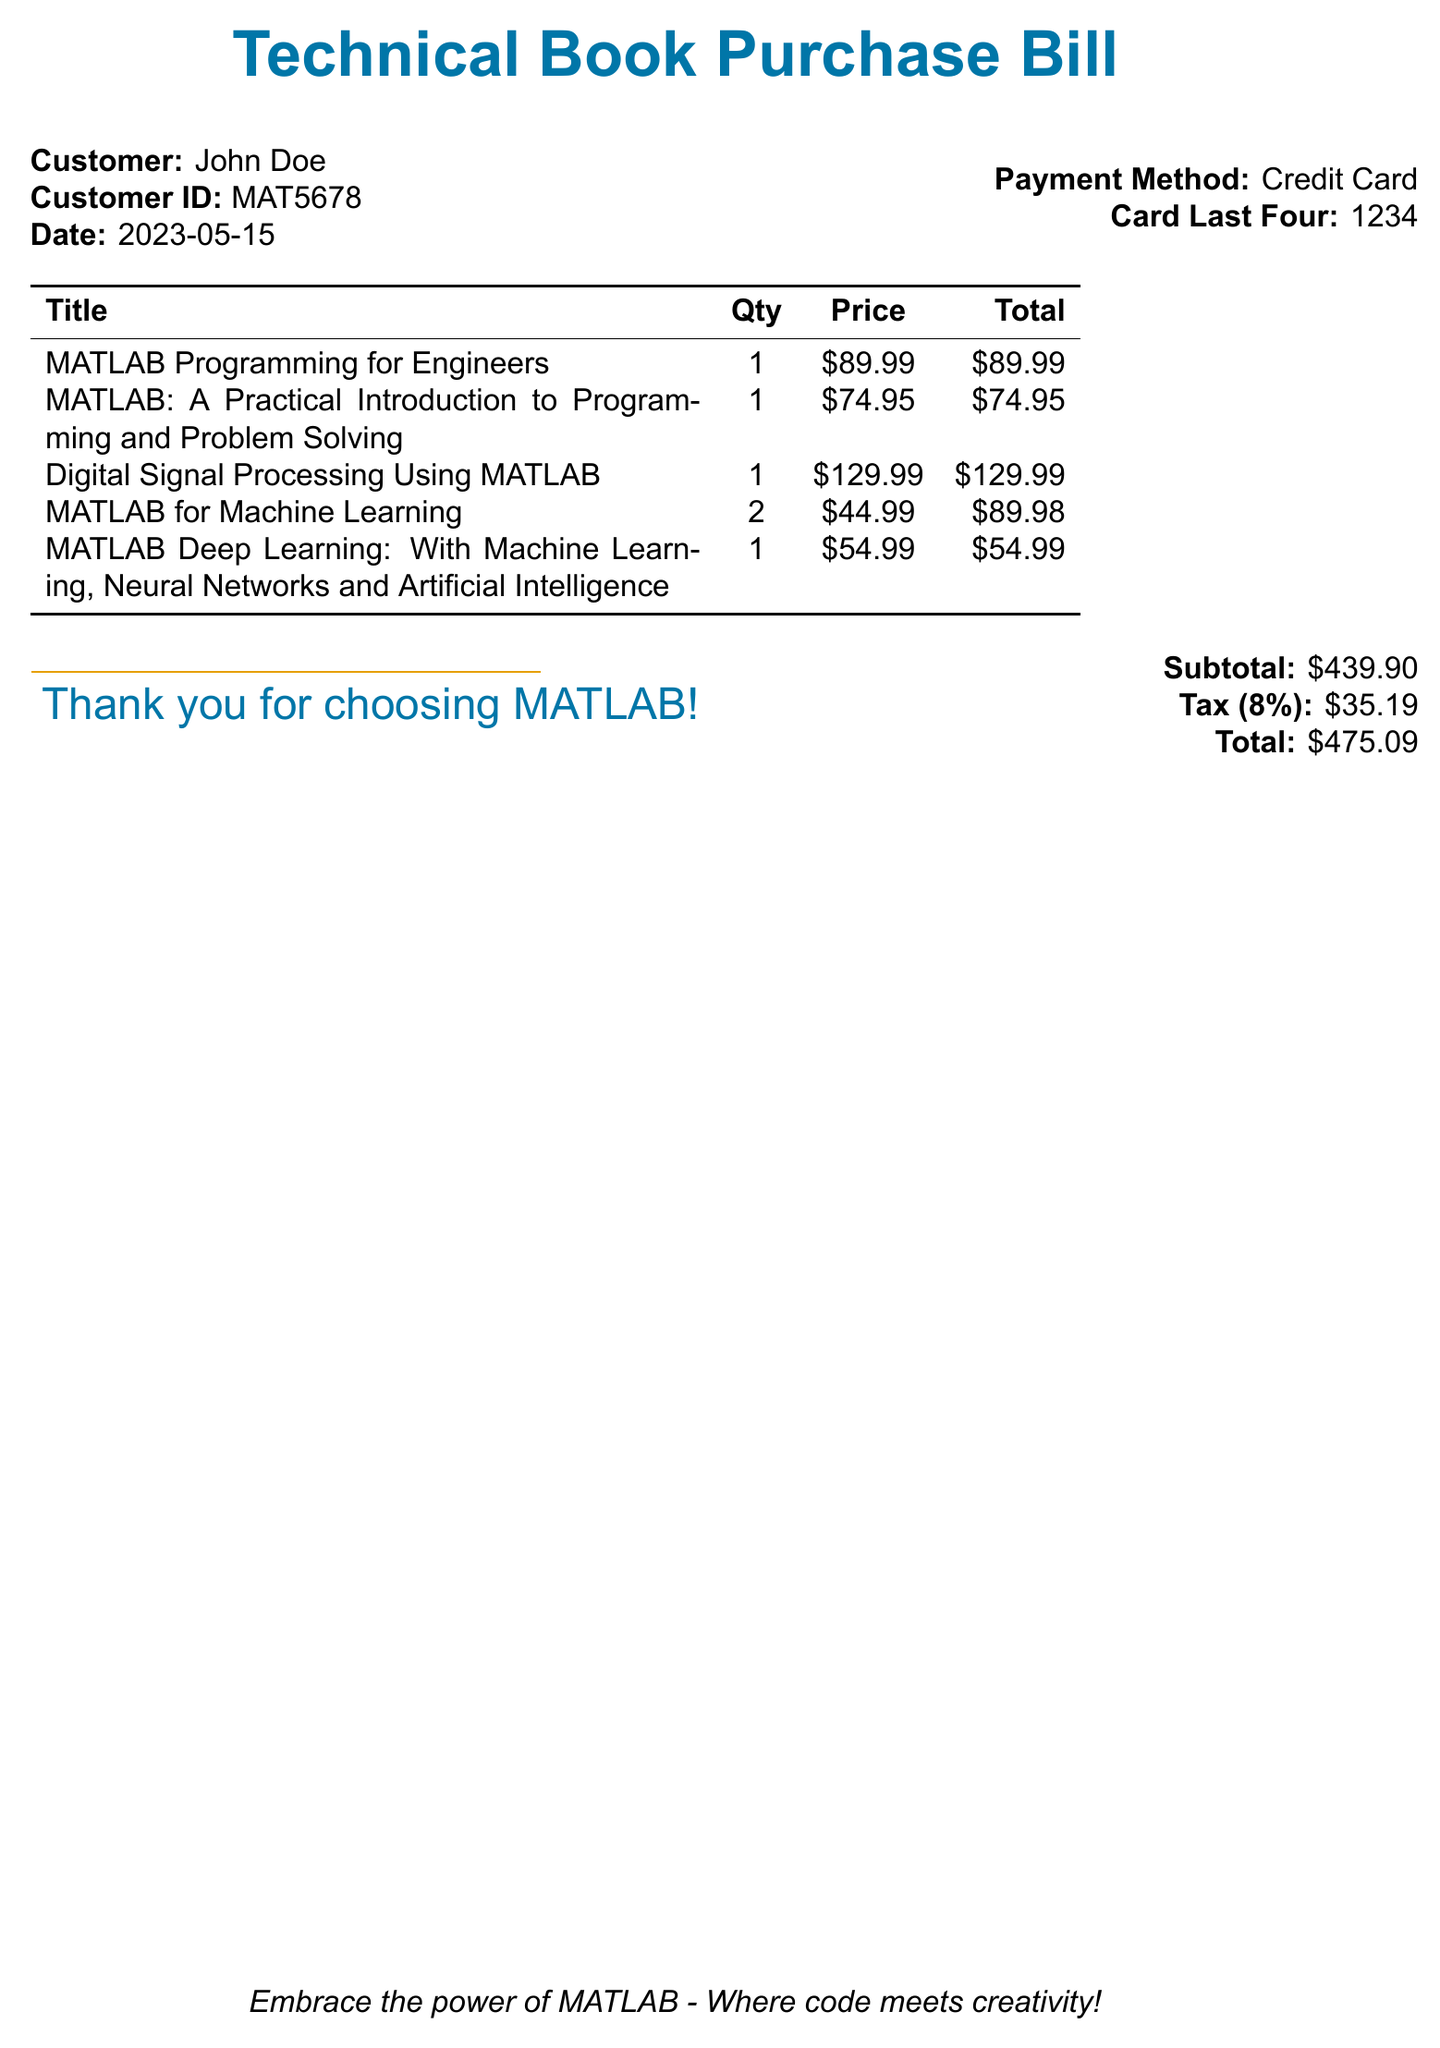What is the customer ID? The customer ID is listed in the document under the customer's information.
Answer: MAT5678 What is the date of the purchase? The date of purchase is stated in the document.
Answer: 2023-05-15 How many copies of "MATLAB for Machine Learning" were purchased? The quantity for this title is shown in the itemized bill.
Answer: 2 What is the total amount before tax? The subtotal is provided in the bill, which indicates the total before tax.
Answer: $439.90 What is the tax percentage applied to the bill? The tax percentage is mentioned in the document.
Answer: 8% What is the total amount due? The total amount is clearly listed as the final payment.
Answer: $475.09 What payment method was used? The payment method is provided in the customer details.
Answer: Credit Card Which book has the highest individual price? The itemized list shows the price for each book, making it easy to identify the highest one.
Answer: Digital Signal Processing Using MATLAB What color is used in the header of the bill? The color used for the bill title is specified in the document.
Answer: Matlab blue 